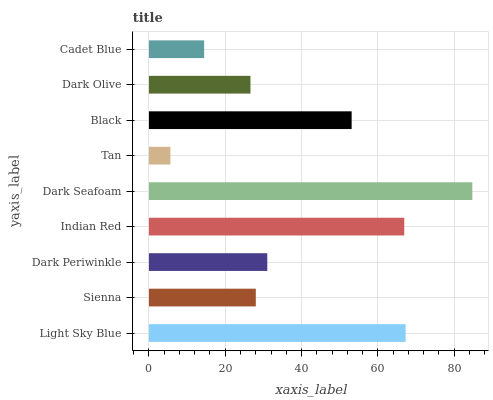Is Tan the minimum?
Answer yes or no. Yes. Is Dark Seafoam the maximum?
Answer yes or no. Yes. Is Sienna the minimum?
Answer yes or no. No. Is Sienna the maximum?
Answer yes or no. No. Is Light Sky Blue greater than Sienna?
Answer yes or no. Yes. Is Sienna less than Light Sky Blue?
Answer yes or no. Yes. Is Sienna greater than Light Sky Blue?
Answer yes or no. No. Is Light Sky Blue less than Sienna?
Answer yes or no. No. Is Dark Periwinkle the high median?
Answer yes or no. Yes. Is Dark Periwinkle the low median?
Answer yes or no. Yes. Is Dark Olive the high median?
Answer yes or no. No. Is Black the low median?
Answer yes or no. No. 